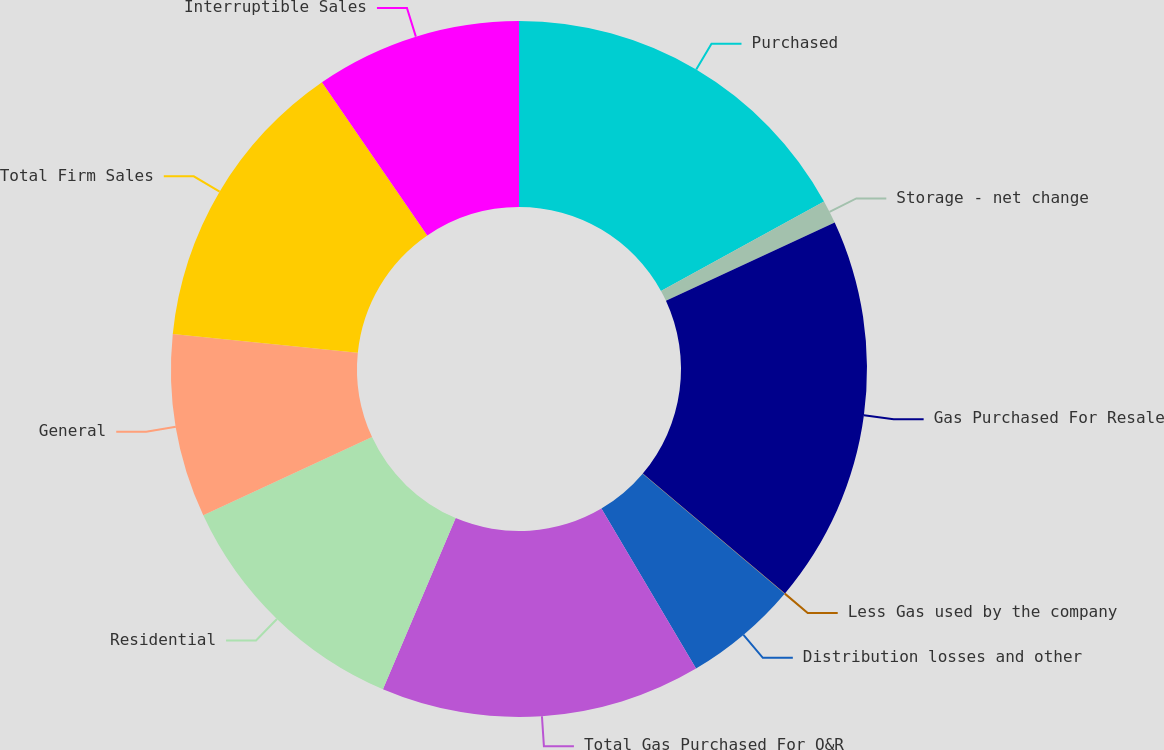Convert chart. <chart><loc_0><loc_0><loc_500><loc_500><pie_chart><fcel>Purchased<fcel>Storage - net change<fcel>Gas Purchased For Resale<fcel>Less Gas used by the company<fcel>Distribution losses and other<fcel>Total Gas Purchased For O&R<fcel>Residential<fcel>General<fcel>Total Firm Sales<fcel>Interruptible Sales<nl><fcel>17.01%<fcel>1.08%<fcel>18.07%<fcel>0.02%<fcel>5.33%<fcel>14.89%<fcel>11.7%<fcel>8.51%<fcel>13.82%<fcel>9.58%<nl></chart> 